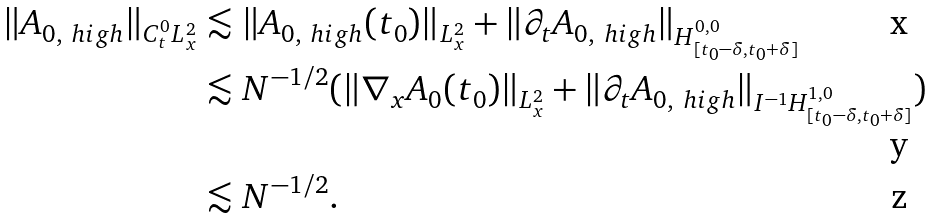<formula> <loc_0><loc_0><loc_500><loc_500>\| A _ { 0 , \ h i g h } \| _ { C ^ { 0 } _ { t } L ^ { 2 } _ { x } } & \lesssim \| A _ { 0 , \ h i g h } ( t _ { 0 } ) \| _ { L ^ { 2 } _ { x } } + \| \partial _ { t } A _ { 0 , \ h i g h } \| _ { H ^ { 0 , 0 } _ { [ t _ { 0 } - \delta , t _ { 0 } + \delta ] } } \\ & \lesssim N ^ { - 1 / 2 } ( \| \nabla _ { x } A _ { 0 } ( t _ { 0 } ) \| _ { L ^ { 2 } _ { x } } + \| \partial _ { t } A _ { 0 , \ h i g h } \| _ { I ^ { - 1 } H ^ { 1 , 0 } _ { [ t _ { 0 } - \delta , t _ { 0 } + \delta ] } } ) \\ & \lesssim N ^ { - 1 / 2 } .</formula> 